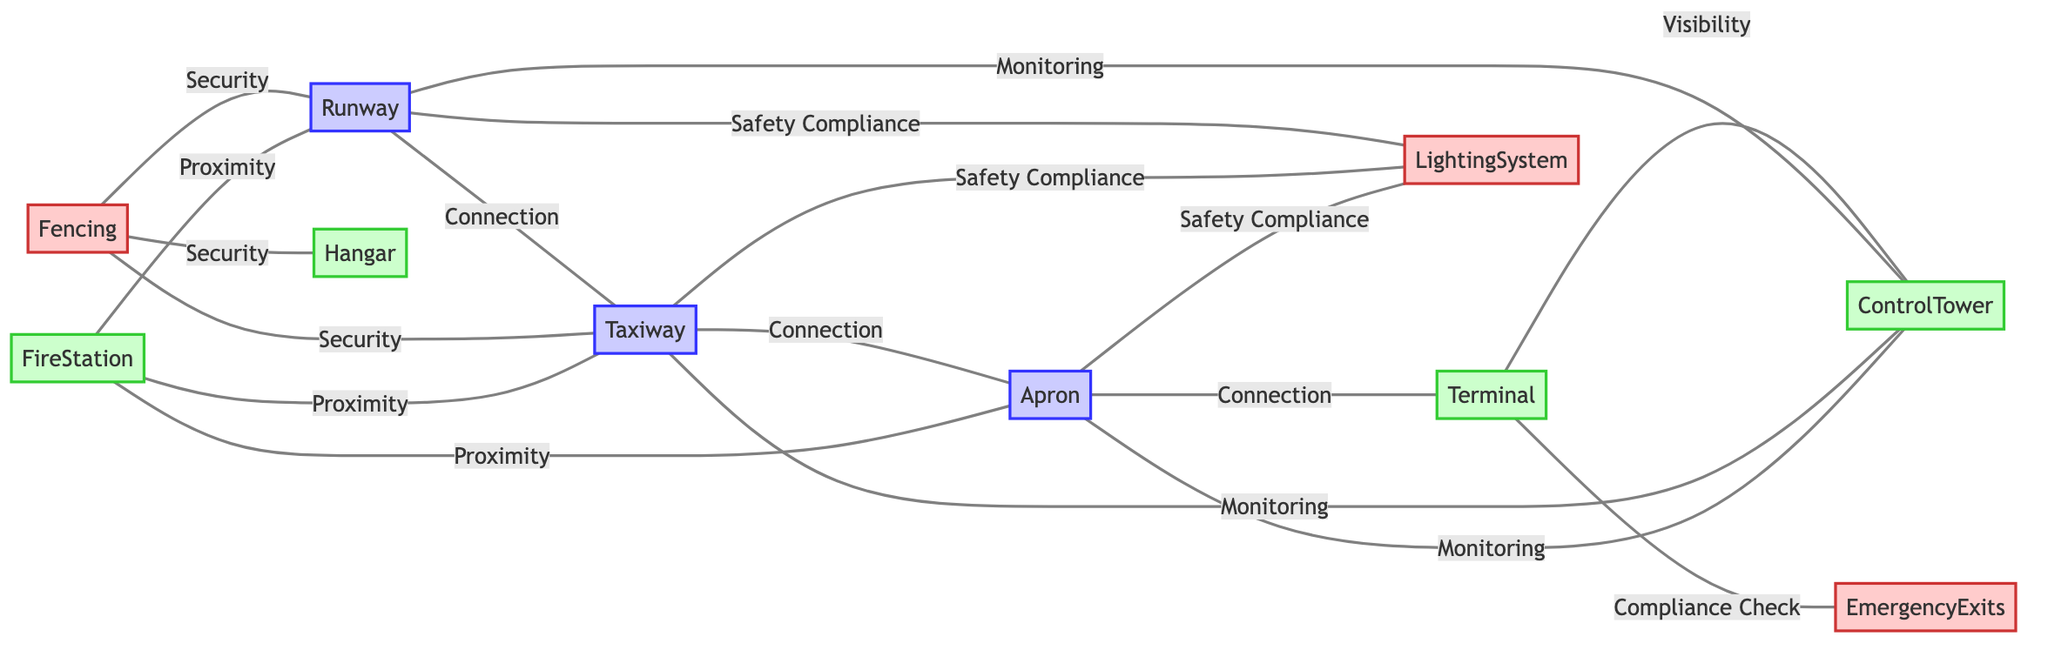What is the total number of nodes in the diagram? The diagram contains 10 nodes: Runway, Taxiway, Apron, Terminal, Control Tower, Hangar, Fire Station, Lighting System, Fencing, and Emergency Exits. Counting these gives us a total of 10.
Answer: 10 Which two zones are connected by a 'Connection' label? The edges labeled 'Connection' includes the following pairs: Runway to Taxiway, Taxiway to Apron, and Apron to Terminal. The pairs indicate direct connections between these zones.
Answer: Runway, Taxiway What is the primary function indicated between the Terminal and the Control Tower? The relationship between the Terminal and the Control Tower is labeled 'Visibility', signifying the importance of sightlines and operational awareness between these crucial airport elements.
Answer: Visibility How many different types of compliance checks are present in the diagram? The diagram shows 'Safety Compliance' and 'Compliance Check' as types of compliance checks. 'Safety Compliance' appears between three different zones and 'Compliance Check' appears once. Counting these gives us two distinct types.
Answer: 2 What is the role of the Fencing in relation to the Runway? The Fencing is connected to the Runway with an edge labeled 'Security'. This suggests that Fencing plays a significant role in providing security for the Runway area, complementing safety standards.
Answer: Security Which zone has the most connections to other zones? The Control Tower has the most connections, linking to Runway, Taxiway, Apron, and Terminal, which indicates its critical monitoring role. Counting these relationships shows it connects to four different zones.
Answer: Control Tower What is the connection relationship between the Fire Station and the Taxiway? The relationship is defined as 'Proximity', indicating that the Fire Station's location provides immediate access to the Taxiway for emergency response purposes. This is specifically indicated in the diagram.
Answer: Proximity How many Safety Compliance relationships are present in the diagram? The diagram includes 'Safety Compliance' relationships between Runway and Lighting System, Taxiway and Lighting System, and Apron and Lighting System. Adding these gives a total of three safety compliance connections.
Answer: 3 What does the edge between Terminal and Emergency Exits signify? The edge is labeled 'Compliance Check', which indicates that there is a compliance check related to the Emergency Exits' accessibility and adherence to safety regulations in the Terminal area.
Answer: Compliance Check 